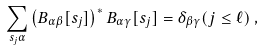<formula> <loc_0><loc_0><loc_500><loc_500>\sum _ { s _ { j } \alpha } \left ( B _ { \alpha \beta } [ s _ { j } ] \right ) ^ { * } B _ { \alpha \gamma } [ s _ { j } ] = \delta _ { \beta \gamma } ( j \leq \ell ) \, ,</formula> 